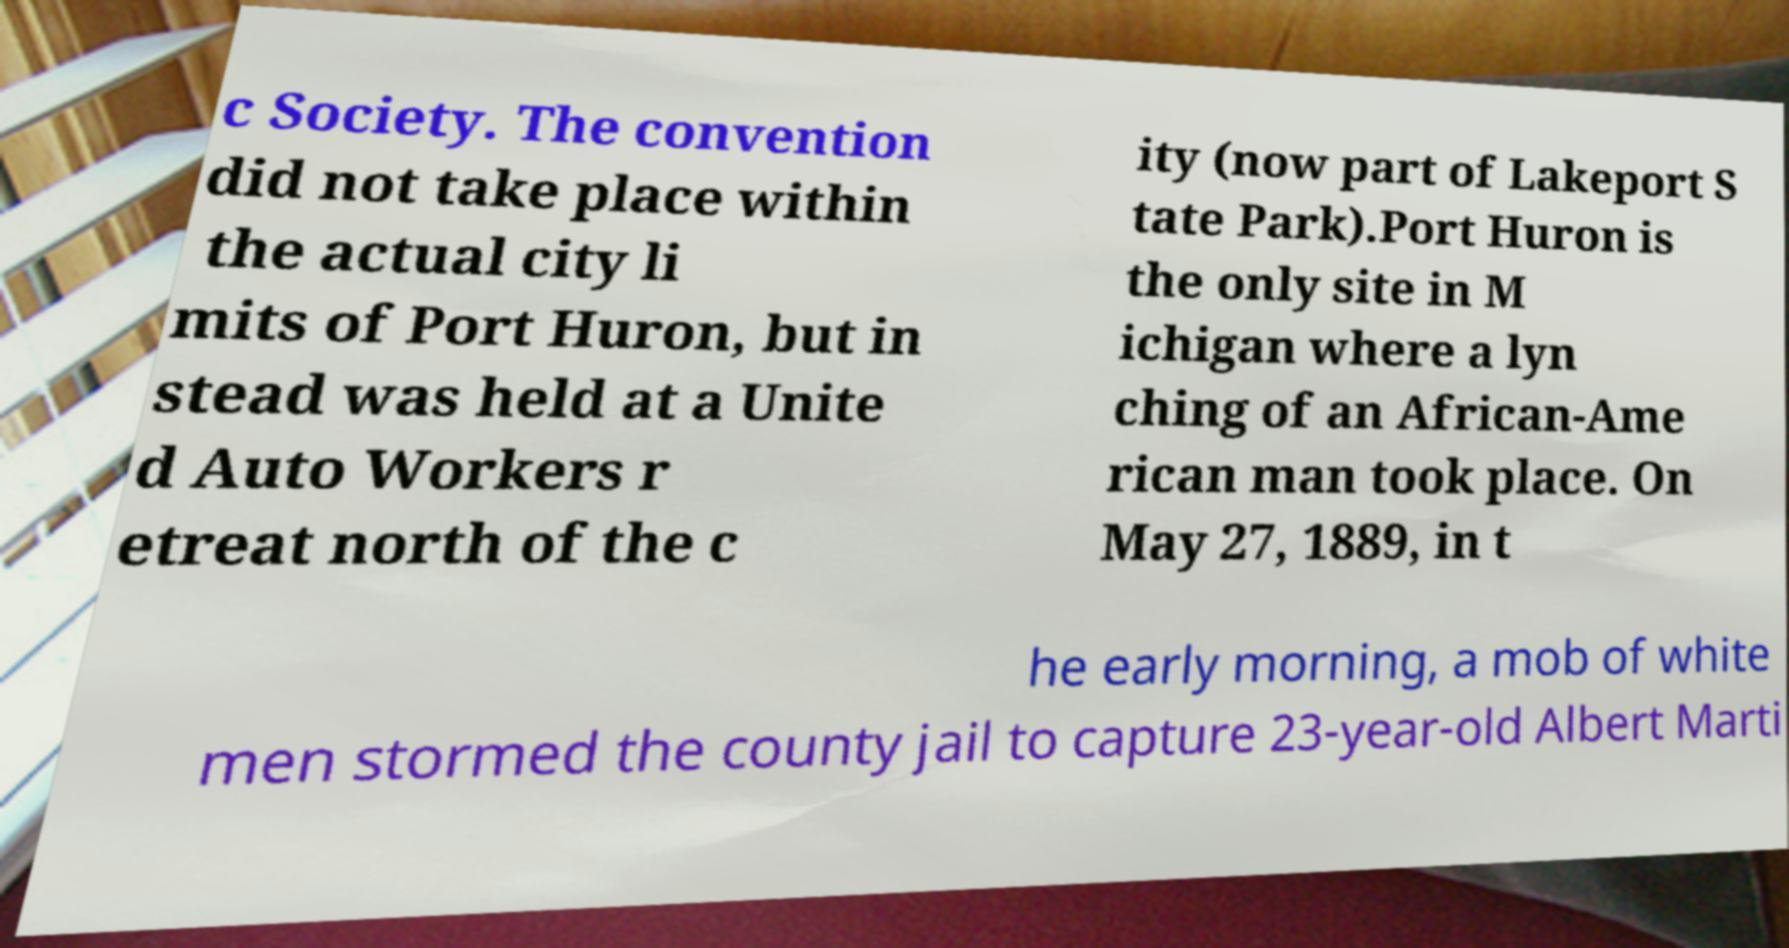Could you assist in decoding the text presented in this image and type it out clearly? c Society. The convention did not take place within the actual city li mits of Port Huron, but in stead was held at a Unite d Auto Workers r etreat north of the c ity (now part of Lakeport S tate Park).Port Huron is the only site in M ichigan where a lyn ching of an African-Ame rican man took place. On May 27, 1889, in t he early morning, a mob of white men stormed the county jail to capture 23-year-old Albert Marti 